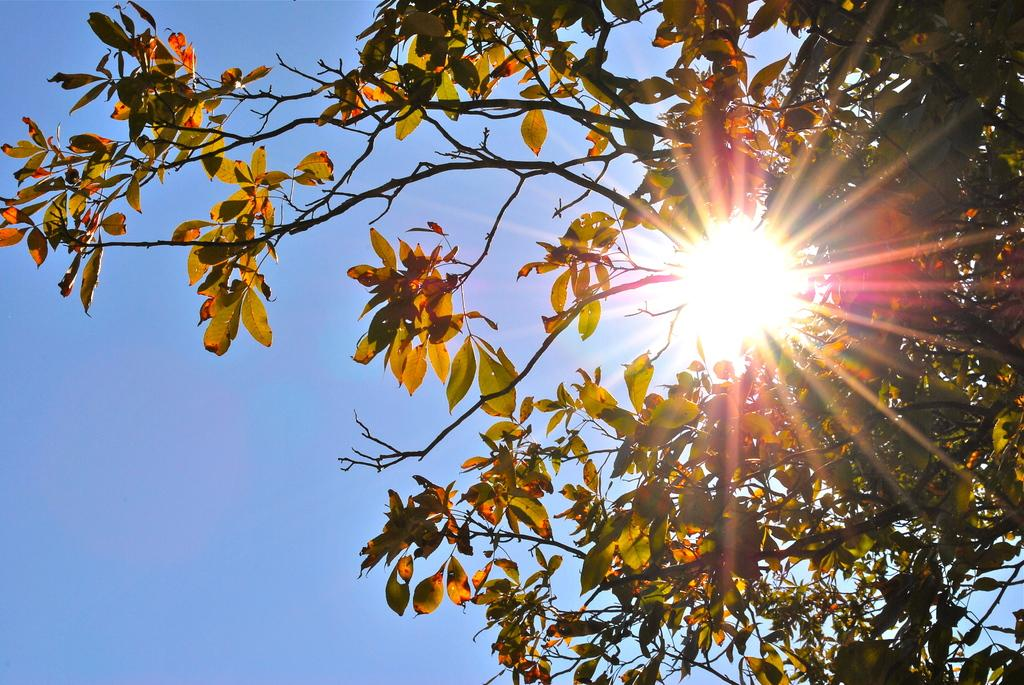What type of natural element can be seen in the image? There is a tree in the image. What is visible in the background of the image? There is a sky visible in the background of the image. Can the sun be seen in the sky? Yes, the sun is observable in the sky. What type of plane is flying over the tree in the image? There is no plane visible in the image; it only features a tree and the sky. Is there any indication that the tree is being used for spying purposes in the image? No, there is no indication of any spying activity in the image, as it only shows a tree and the sky. 